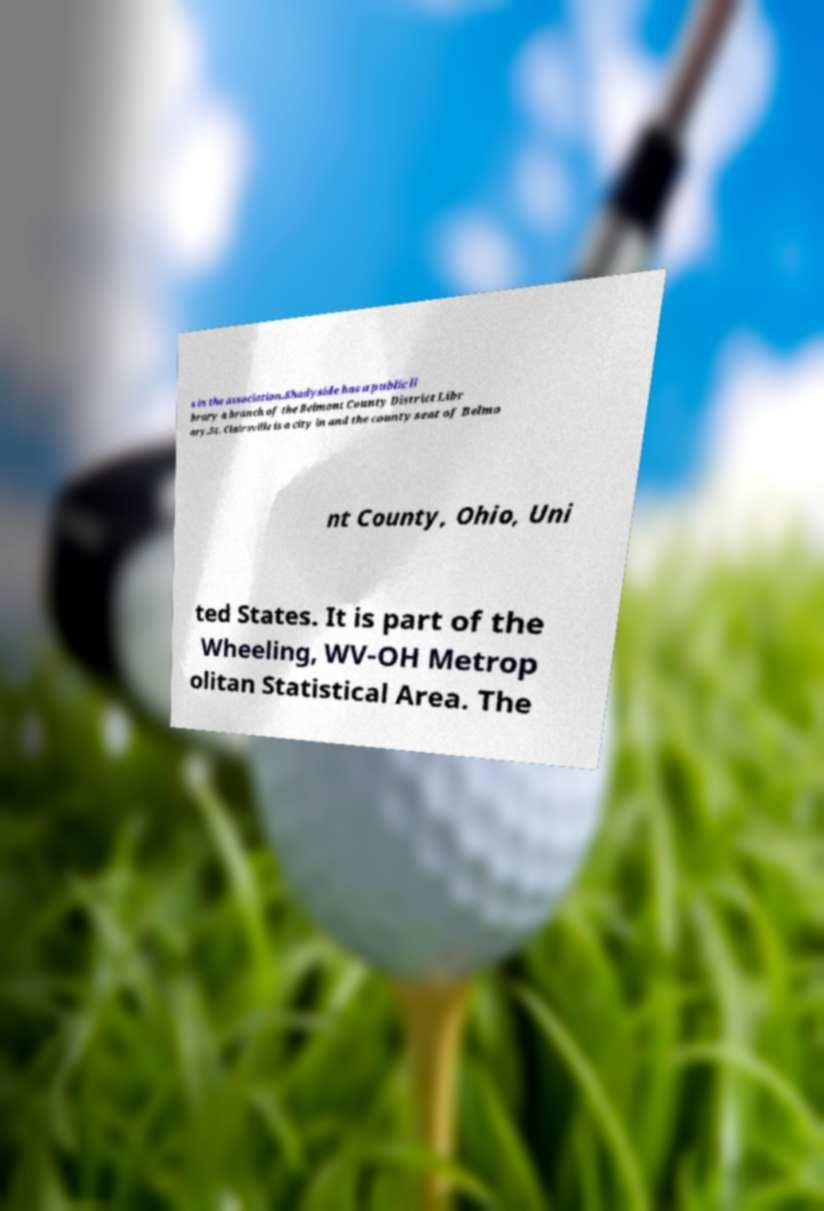Can you read and provide the text displayed in the image?This photo seems to have some interesting text. Can you extract and type it out for me? s in the association.Shadyside has a public li brary a branch of the Belmont County District Libr ary.St. Clairsville is a city in and the county seat of Belmo nt County, Ohio, Uni ted States. It is part of the Wheeling, WV-OH Metrop olitan Statistical Area. The 